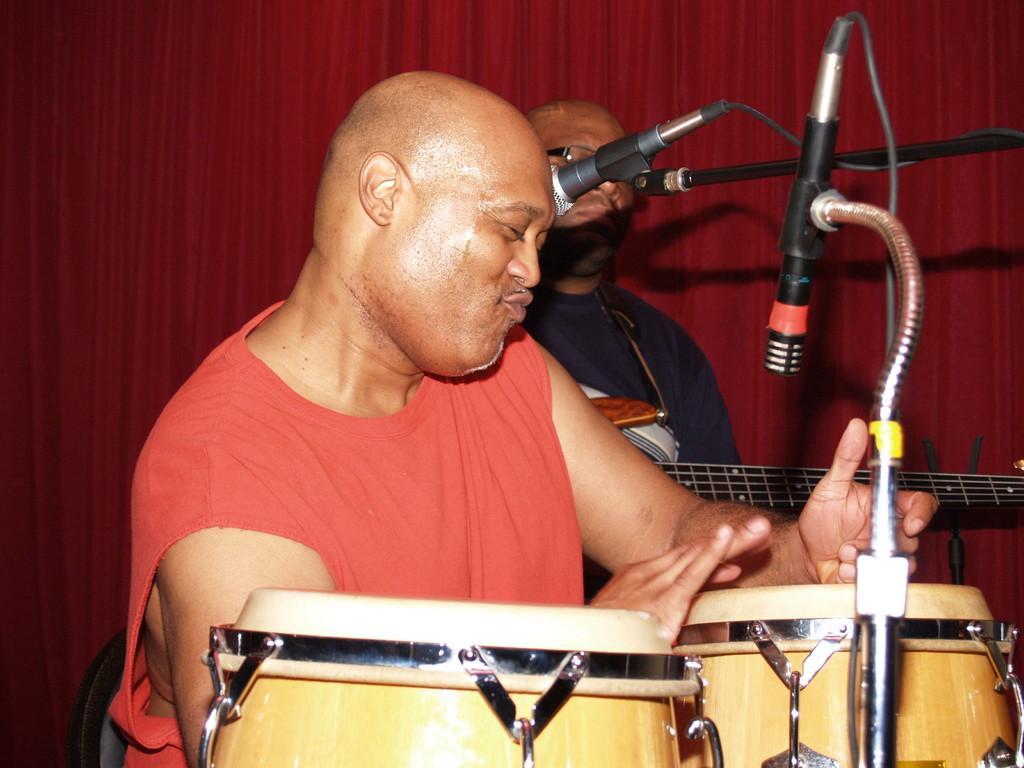How would you summarize this image in a sentence or two? In this picture there is a man in the center of the image, it seems to be he is playing tabla and there are mics on the right side of the image, there is another man, by holding guitar in his hands and there is a red color curtain in the background area of the image. 